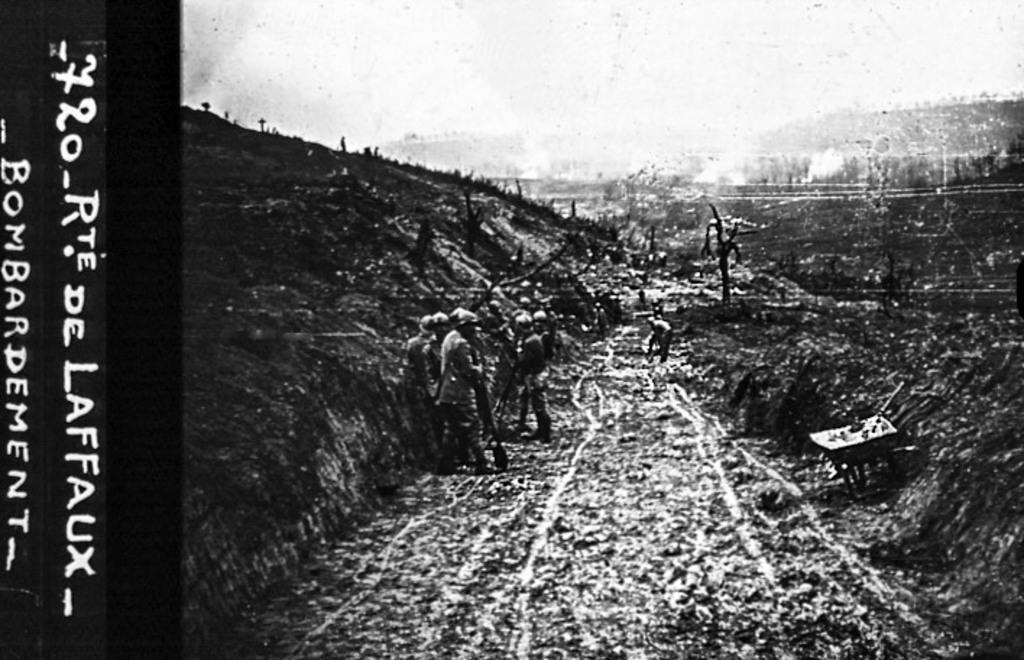<image>
Write a terse but informative summary of the picture. A very old picture is labelled Rte De Laffaux Bombardement. 